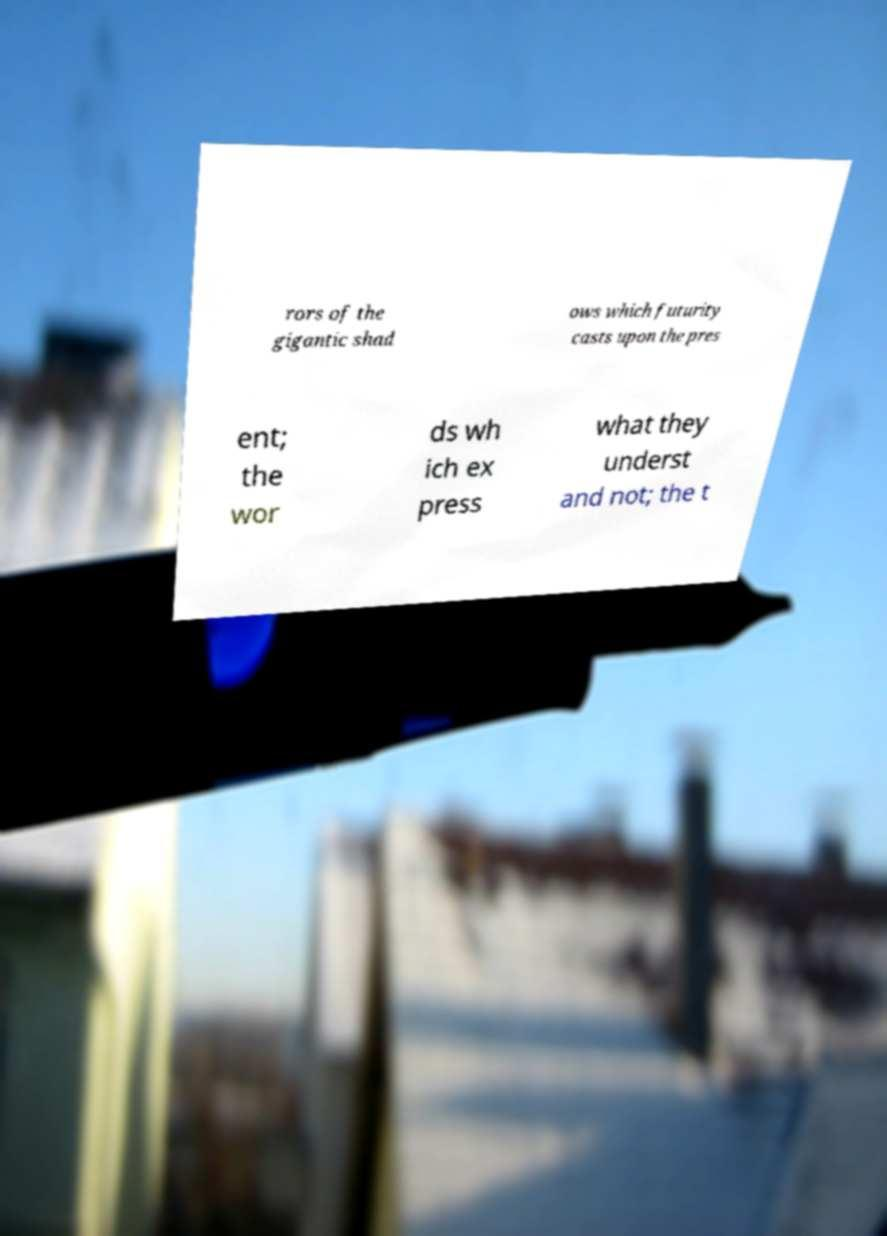For documentation purposes, I need the text within this image transcribed. Could you provide that? rors of the gigantic shad ows which futurity casts upon the pres ent; the wor ds wh ich ex press what they underst and not; the t 